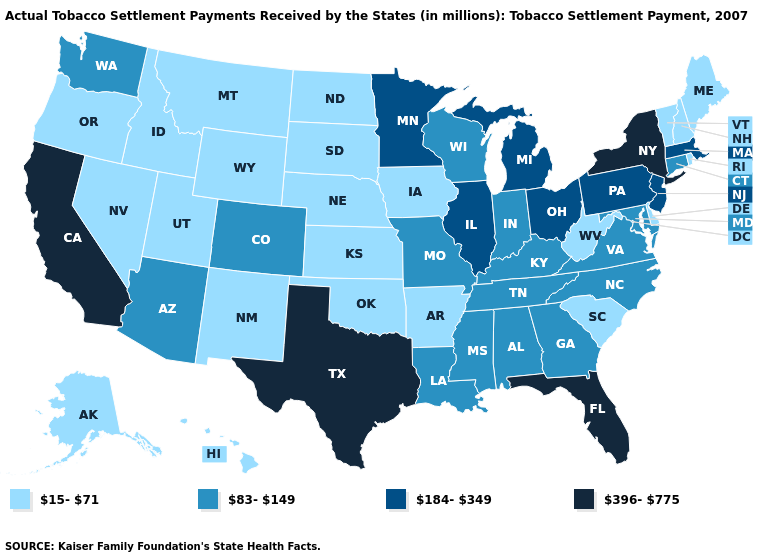Among the states that border South Carolina , which have the highest value?
Answer briefly. Georgia, North Carolina. Does Kentucky have the highest value in the USA?
Short answer required. No. Name the states that have a value in the range 15-71?
Quick response, please. Alaska, Arkansas, Delaware, Hawaii, Idaho, Iowa, Kansas, Maine, Montana, Nebraska, Nevada, New Hampshire, New Mexico, North Dakota, Oklahoma, Oregon, Rhode Island, South Carolina, South Dakota, Utah, Vermont, West Virginia, Wyoming. Which states hav the highest value in the MidWest?
Quick response, please. Illinois, Michigan, Minnesota, Ohio. What is the highest value in the USA?
Answer briefly. 396-775. What is the value of South Dakota?
Be succinct. 15-71. What is the value of California?
Answer briefly. 396-775. What is the highest value in the USA?
Give a very brief answer. 396-775. Name the states that have a value in the range 83-149?
Concise answer only. Alabama, Arizona, Colorado, Connecticut, Georgia, Indiana, Kentucky, Louisiana, Maryland, Mississippi, Missouri, North Carolina, Tennessee, Virginia, Washington, Wisconsin. Which states have the lowest value in the South?
Give a very brief answer. Arkansas, Delaware, Oklahoma, South Carolina, West Virginia. Among the states that border Vermont , which have the lowest value?
Short answer required. New Hampshire. What is the value of Illinois?
Concise answer only. 184-349. What is the value of South Carolina?
Keep it brief. 15-71. What is the lowest value in the USA?
Write a very short answer. 15-71. 